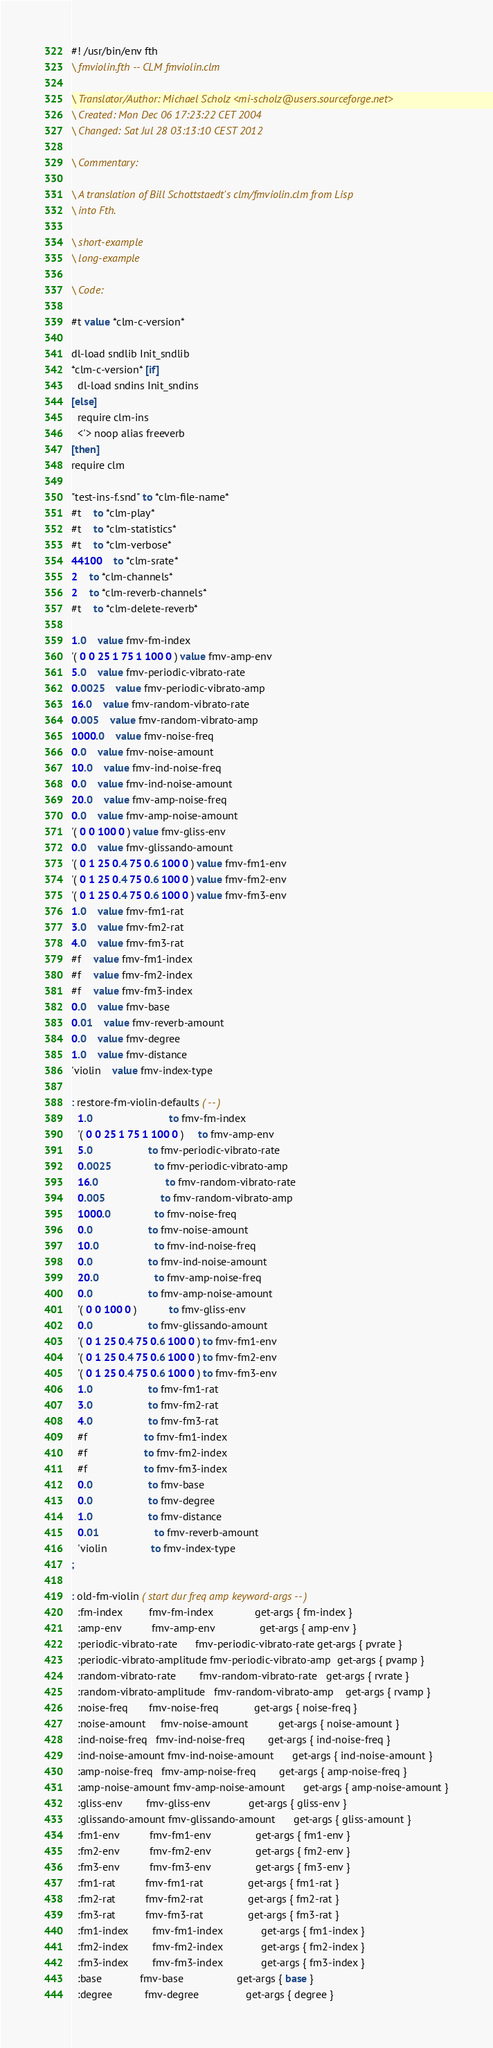Convert code to text. <code><loc_0><loc_0><loc_500><loc_500><_Forth_>#! /usr/bin/env fth
\ fmviolin.fth -- CLM fmviolin.clm

\ Translator/Author: Michael Scholz <mi-scholz@users.sourceforge.net>
\ Created: Mon Dec 06 17:23:22 CET 2004
\ Changed: Sat Jul 28 03:13:10 CEST 2012

\ Commentary:

\ A translation of Bill Schottstaedt's clm/fmviolin.clm from Lisp
\ into Fth.

\ short-example
\ long-example

\ Code:

#t value *clm-c-version*

dl-load sndlib Init_sndlib
*clm-c-version* [if]
  dl-load sndins Init_sndins
[else]
  require clm-ins
  <'> noop alias freeverb
[then]
require clm

"test-ins-f.snd" to *clm-file-name*
#t	to *clm-play*
#t	to *clm-statistics*
#t	to *clm-verbose*
44100	to *clm-srate*
2	to *clm-channels*
2	to *clm-reverb-channels*
#t	to *clm-delete-reverb*

1.0	value fmv-fm-index                   
'( 0 0 25 1 75 1 100 0 ) value fmv-amp-env                    
5.0	value fmv-periodic-vibrato-rate      
0.0025	value fmv-periodic-vibrato-amp
16.0	value fmv-random-vibrato-rate        
0.005	value fmv-random-vibrato-amp
1000.0	value fmv-noise-freq                 
0.0	value fmv-noise-amount               
10.0	value fmv-ind-noise-freq             
0.0	value fmv-ind-noise-amount           
20.0	value fmv-amp-noise-freq             
0.0	value fmv-amp-noise-amount           
'( 0 0 100 0 ) value fmv-gliss-env                  
0.0	value fmv-glissando-amount           
'( 0 1 25 0.4 75 0.6 100 0 ) value fmv-fm1-env                    
'( 0 1 25 0.4 75 0.6 100 0 ) value fmv-fm2-env                    
'( 0 1 25 0.4 75 0.6 100 0 ) value fmv-fm3-env                    
1.0	value fmv-fm1-rat                    
3.0	value fmv-fm2-rat                    
4.0	value fmv-fm3-rat                    
#f	value fmv-fm1-index                  
#f	value fmv-fm2-index                  
#f	value fmv-fm3-index                  
0.0	value fmv-base                       
0.01	value fmv-reverb-amount              
0.0	value fmv-degree                     
1.0	value fmv-distance                   
'violin	value fmv-index-type                 

: restore-fm-violin-defaults ( -- )
  1.0                          to fmv-fm-index                   
  '( 0 0 25 1 75 1 100 0 )     to fmv-amp-env                    
  5.0			       to fmv-periodic-vibrato-rate      
  0.0025		       to fmv-periodic-vibrato-amp
  16.0		               to fmv-random-vibrato-rate        
  0.005			       to fmv-random-vibrato-amp
  1000.0		       to fmv-noise-freq                 
  0.0			       to fmv-noise-amount               
  10.0			       to fmv-ind-noise-freq             
  0.0			       to fmv-ind-noise-amount           
  20.0			       to fmv-amp-noise-freq             
  0.0			       to fmv-amp-noise-amount           
  '( 0 0 100 0 )	       to fmv-gliss-env                  
  0.0			       to fmv-glissando-amount           
  '( 0 1 25 0.4 75 0.6 100 0 ) to fmv-fm1-env                    
  '( 0 1 25 0.4 75 0.6 100 0 ) to fmv-fm2-env                    
  '( 0 1 25 0.4 75 0.6 100 0 ) to fmv-fm3-env                    
  1.0			       to fmv-fm1-rat                    
  3.0			       to fmv-fm2-rat                    
  4.0			       to fmv-fm3-rat                    
  #f			       to fmv-fm1-index                  
  #f			       to fmv-fm2-index                  
  #f			       to fmv-fm3-index                  
  0.0			       to fmv-base                       
  0.0			       to fmv-degree                     
  1.0			       to fmv-distance                   
  0.01			       to fmv-reverb-amount              
  'violin		       to fmv-index-type                 
;

: old-fm-violin ( start dur freq amp keyword-args -- )
  :fm-index         fmv-fm-index              get-args { fm-index }
  :amp-env          fmv-amp-env               get-args { amp-env }
  :periodic-vibrato-rate      fmv-periodic-vibrato-rate get-args { pvrate }
  :periodic-vibrato-amplitude fmv-periodic-vibrato-amp  get-args { pvamp }
  :random-vibrato-rate        fmv-random-vibrato-rate   get-args { rvrate }
  :random-vibrato-amplitude   fmv-random-vibrato-amp    get-args { rvamp }
  :noise-freq       fmv-noise-freq            get-args { noise-freq }
  :noise-amount     fmv-noise-amount          get-args { noise-amount }
  :ind-noise-freq   fmv-ind-noise-freq        get-args { ind-noise-freq }
  :ind-noise-amount fmv-ind-noise-amount      get-args { ind-noise-amount }
  :amp-noise-freq   fmv-amp-noise-freq        get-args { amp-noise-freq }
  :amp-noise-amount fmv-amp-noise-amount      get-args { amp-noise-amount }
  :gliss-env        fmv-gliss-env             get-args { gliss-env }
  :glissando-amount fmv-glissando-amount      get-args { gliss-amount }
  :fm1-env          fmv-fm1-env               get-args { fm1-env }
  :fm2-env          fmv-fm2-env               get-args { fm2-env }
  :fm3-env          fmv-fm3-env               get-args { fm3-env }
  :fm1-rat          fmv-fm1-rat               get-args { fm1-rat }
  :fm2-rat          fmv-fm2-rat               get-args { fm2-rat }
  :fm3-rat          fmv-fm3-rat               get-args { fm3-rat }
  :fm1-index        fmv-fm1-index             get-args { fm1-index }
  :fm2-index        fmv-fm2-index             get-args { fm2-index }
  :fm3-index        fmv-fm3-index             get-args { fm3-index }
  :base             fmv-base                  get-args { base }
  :degree           fmv-degree                get-args { degree }</code> 